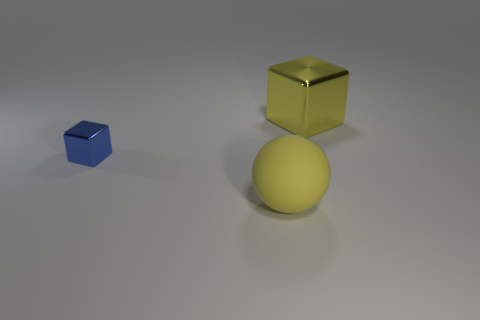Add 2 balls. How many objects exist? 5 Subtract all balls. How many objects are left? 2 Add 2 yellow spheres. How many yellow spheres exist? 3 Subtract 0 red blocks. How many objects are left? 3 Subtract all green shiny objects. Subtract all blue metal cubes. How many objects are left? 2 Add 3 large yellow metal cubes. How many large yellow metal cubes are left? 4 